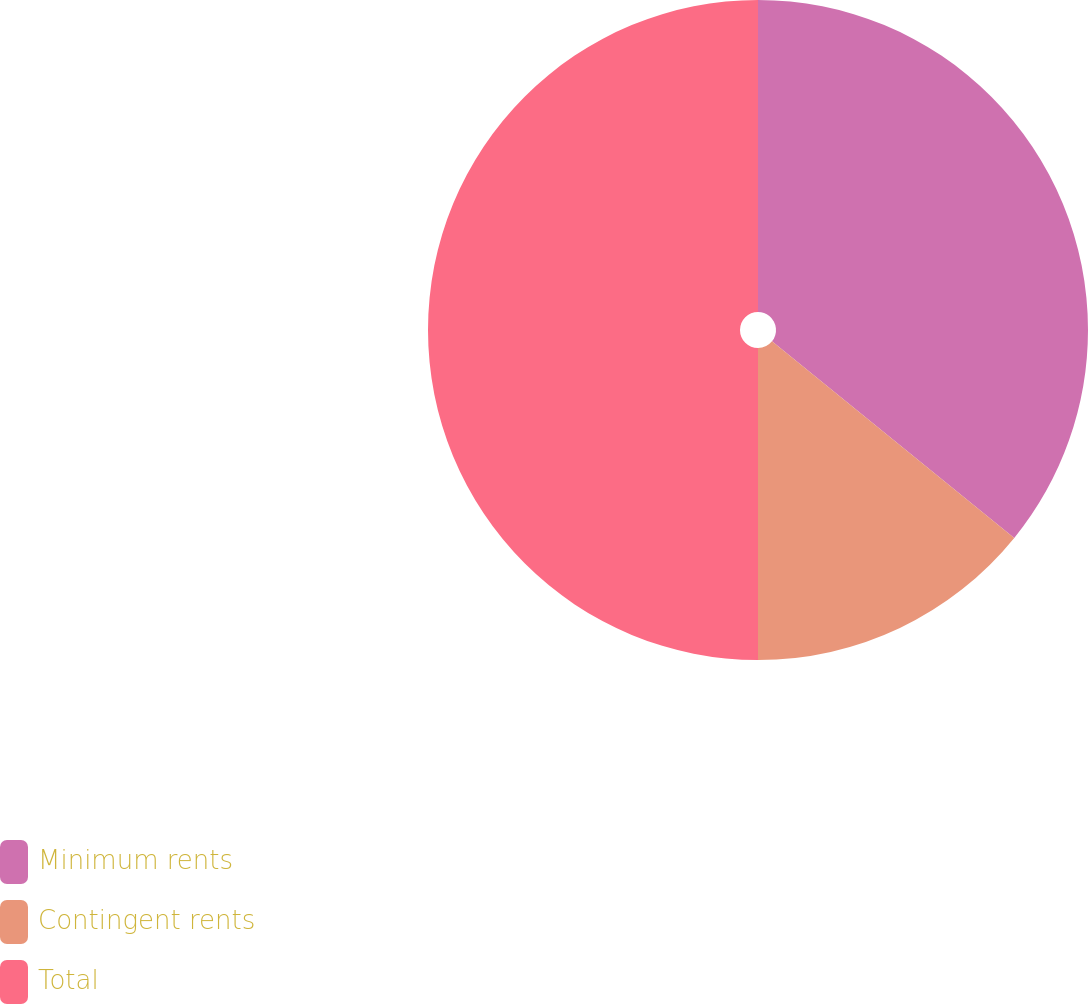Convert chart. <chart><loc_0><loc_0><loc_500><loc_500><pie_chart><fcel>Minimum rents<fcel>Contingent rents<fcel>Total<nl><fcel>35.85%<fcel>14.15%<fcel>50.0%<nl></chart> 